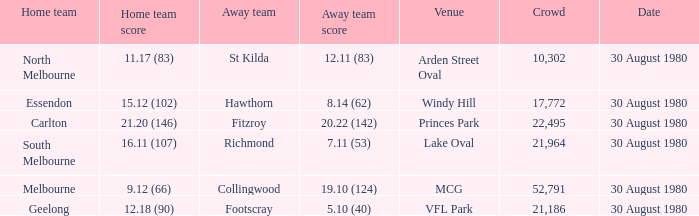At lake oval, what is the home team's points tally? 16.11 (107). 